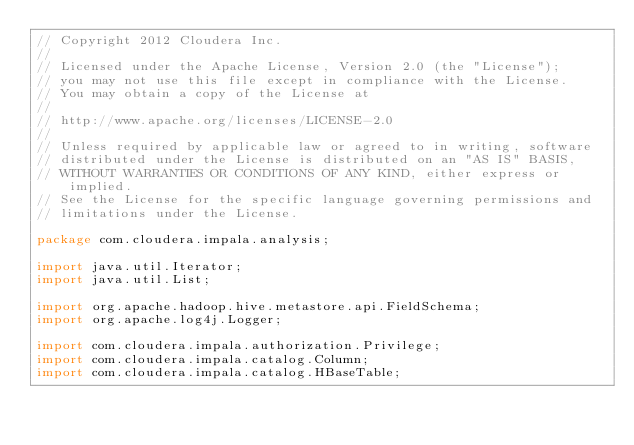Convert code to text. <code><loc_0><loc_0><loc_500><loc_500><_Java_>// Copyright 2012 Cloudera Inc.
//
// Licensed under the Apache License, Version 2.0 (the "License");
// you may not use this file except in compliance with the License.
// You may obtain a copy of the License at
//
// http://www.apache.org/licenses/LICENSE-2.0
//
// Unless required by applicable law or agreed to in writing, software
// distributed under the License is distributed on an "AS IS" BASIS,
// WITHOUT WARRANTIES OR CONDITIONS OF ANY KIND, either express or implied.
// See the License for the specific language governing permissions and
// limitations under the License.

package com.cloudera.impala.analysis;

import java.util.Iterator;
import java.util.List;

import org.apache.hadoop.hive.metastore.api.FieldSchema;
import org.apache.log4j.Logger;

import com.cloudera.impala.authorization.Privilege;
import com.cloudera.impala.catalog.Column;
import com.cloudera.impala.catalog.HBaseTable;</code> 